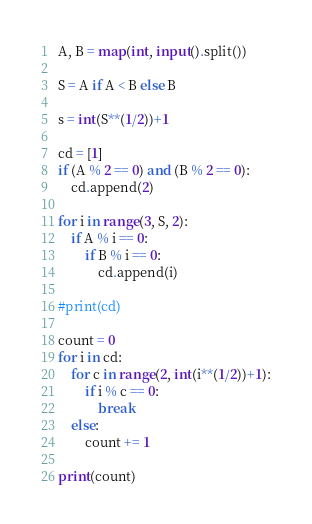Convert code to text. <code><loc_0><loc_0><loc_500><loc_500><_Python_>A, B = map(int, input().split())

S = A if A < B else B

s = int(S**(1/2))+1

cd = [1]
if (A % 2 == 0) and (B % 2 == 0):
    cd.append(2)

for i in range(3, S, 2):
    if A % i == 0:
        if B % i == 0:
            cd.append(i)
            
#print(cd)

count = 0
for i in cd:
    for c in range(2, int(i**(1/2))+1):
        if i % c == 0:
            break
    else:
        count += 1
         
print(count)</code> 